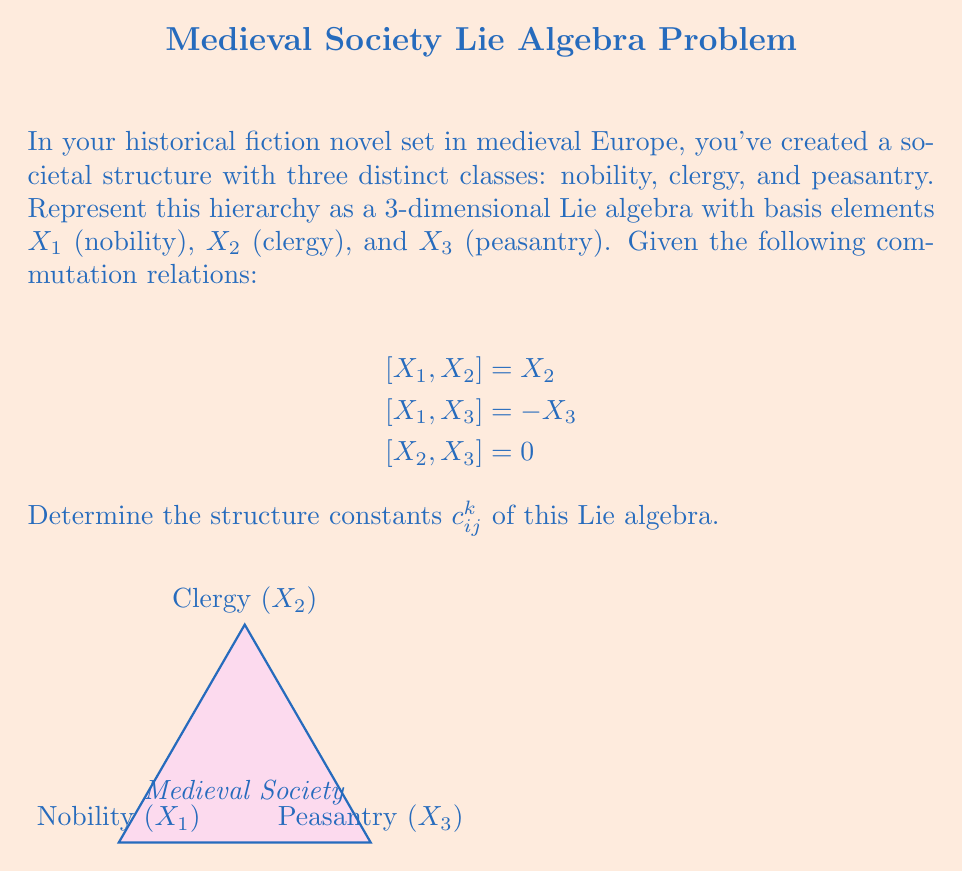Give your solution to this math problem. To determine the structure constants $c_{ij}^k$, we need to express each commutation relation in terms of the general form:

$$[X_i, X_j] = \sum_{k=1}^3 c_{ij}^k X_k$$

Step 1: Analyze $[X_1, X_2] = X_2$
This implies $c_{12}^1 = 0$, $c_{12}^2 = 1$, and $c_{12}^3 = 0$.

Step 2: Analyze $[X_1, X_3] = -X_3$
This implies $c_{13}^1 = 0$, $c_{13}^2 = 0$, and $c_{13}^3 = -1$.

Step 3: Analyze $[X_2, X_3] = 0$
This implies $c_{23}^1 = 0$, $c_{23}^2 = 0$, and $c_{23}^3 = 0$.

Step 4: Apply antisymmetry property of Lie brackets
$[X_i, X_j] = -[X_j, X_i]$ implies:
$c_{21}^k = -c_{12}^k$, $c_{31}^k = -c_{13}^k$, and $c_{32}^k = -c_{23}^k$ for $k = 1, 2, 3$.

Step 5: Compile all non-zero structure constants
The non-zero structure constants are:
$c_{12}^2 = 1$, $c_{13}^3 = -1$, $c_{21}^2 = -1$, and $c_{31}^3 = 1$.
Answer: $c_{12}^2 = 1$, $c_{13}^3 = -1$, $c_{21}^2 = -1$, $c_{31}^3 = 1$; all others are zero. 